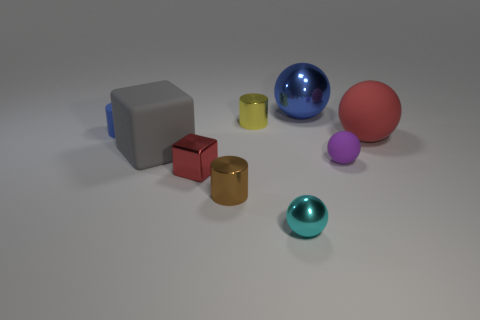There is a big sphere that is behind the large red sphere; is there a small purple sphere behind it?
Provide a short and direct response. No. There is a purple sphere that is the same size as the brown cylinder; what is its material?
Your answer should be compact. Rubber. Are there any red cubes of the same size as the yellow cylinder?
Keep it short and to the point. Yes. Are there an equal number of red cubes and tiny brown rubber objects?
Offer a terse response. No. What is the red thing that is behind the rubber block made of?
Ensure brevity in your answer.  Rubber. Are the cube that is to the right of the gray matte object and the big red object made of the same material?
Keep it short and to the point. No. There is a yellow metal thing that is the same size as the brown metal object; what shape is it?
Ensure brevity in your answer.  Cylinder. What number of matte cylinders have the same color as the tiny metal block?
Offer a terse response. 0. Are there fewer small matte cylinders that are to the right of the small cyan ball than tiny yellow cylinders that are in front of the purple rubber sphere?
Ensure brevity in your answer.  No. Are there any matte cylinders to the right of the tiny purple rubber thing?
Your answer should be compact. No. 